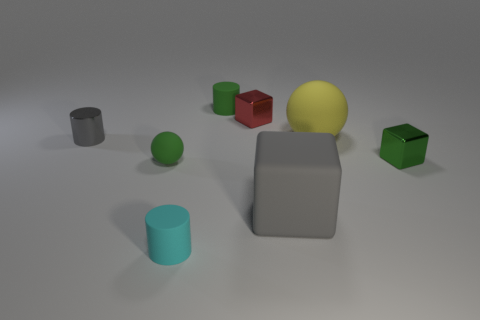What can you infer about the light source in this image? The shadows cast by the objects suggest that the light source is positioned above and to the right of the scene, providing an even illumination across the entire arrangement of objects.  If these objects represent a cityscape, which could be the tallest building? If this collection of objects were to mimic a cityscape, the tallest building could be represented by the gray block, as it has the most significant height relative to the other objects, giving the impression of a skyscraper. 